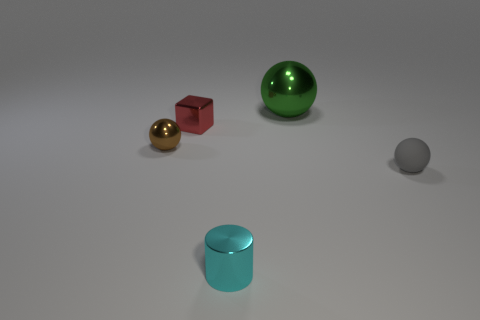What is the material of the tiny thing behind the tiny brown ball?
Provide a succinct answer. Metal. How many objects are small gray rubber things or shiny balls that are to the right of the cyan thing?
Keep it short and to the point. 2. What number of other things are there of the same size as the cyan metal object?
Ensure brevity in your answer.  3. What material is the green object that is the same shape as the small brown thing?
Your answer should be compact. Metal. Is the number of small gray matte things that are right of the tiny metal block greater than the number of blue rubber objects?
Offer a very short reply. Yes. Is there any other thing that has the same color as the small metallic ball?
Offer a very short reply. No. The small red object that is the same material as the cylinder is what shape?
Provide a short and direct response. Cube. Is the tiny ball that is on the left side of the green metal ball made of the same material as the gray sphere?
Offer a very short reply. No. How many things are on the left side of the small rubber sphere and right of the cyan cylinder?
Provide a short and direct response. 1. What material is the small gray sphere?
Keep it short and to the point. Rubber. 